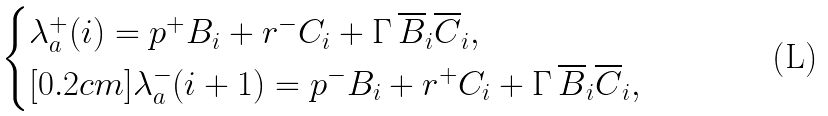Convert formula to latex. <formula><loc_0><loc_0><loc_500><loc_500>\begin{cases} \lambda _ { a } ^ { + } ( i ) = p ^ { + } B _ { i } + r ^ { - } C _ { i } + \Gamma \, \overline { B } _ { i } \overline { C } _ { i } , \\ [ 0 . 2 c m ] \lambda _ { a } ^ { - } ( i + 1 ) = p ^ { - } B _ { i } + r ^ { + } C _ { i } + \Gamma \, \overline { B } _ { i } \overline { C } _ { i } , \end{cases}</formula> 